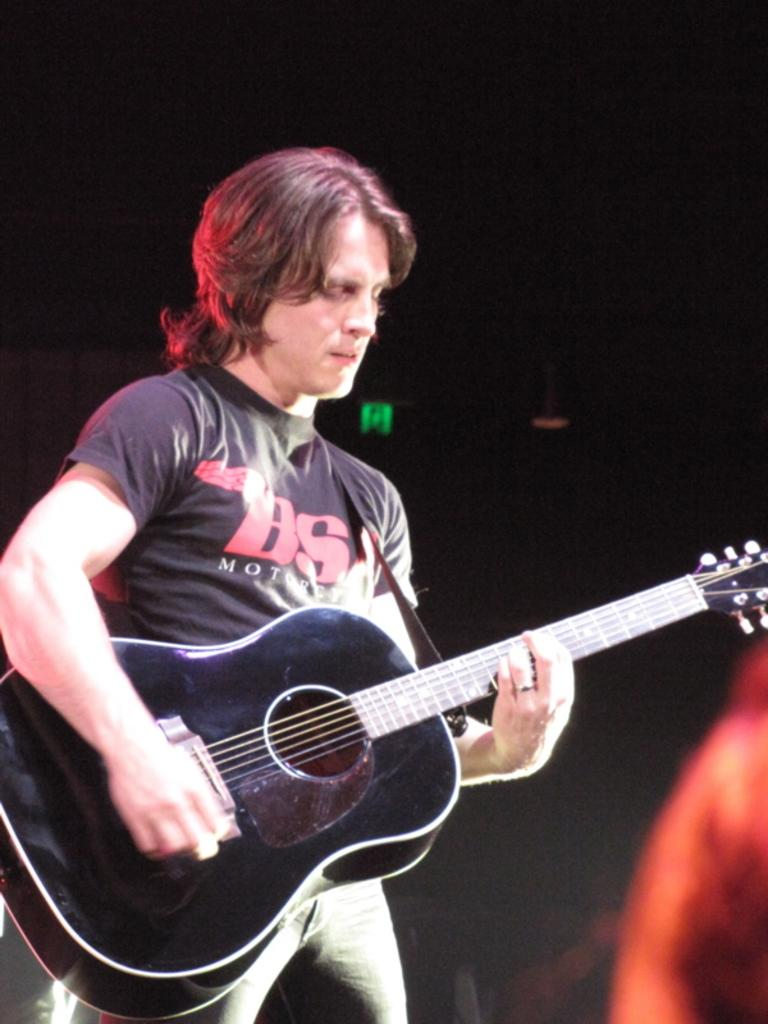What is the main subject of the image? There is a man in the image. What is the man holding in the image? The man is holding a guitar. What type of waves can be seen crashing against the dock in the image? There is no dock or waves present in the image; it features a man holding a guitar. 